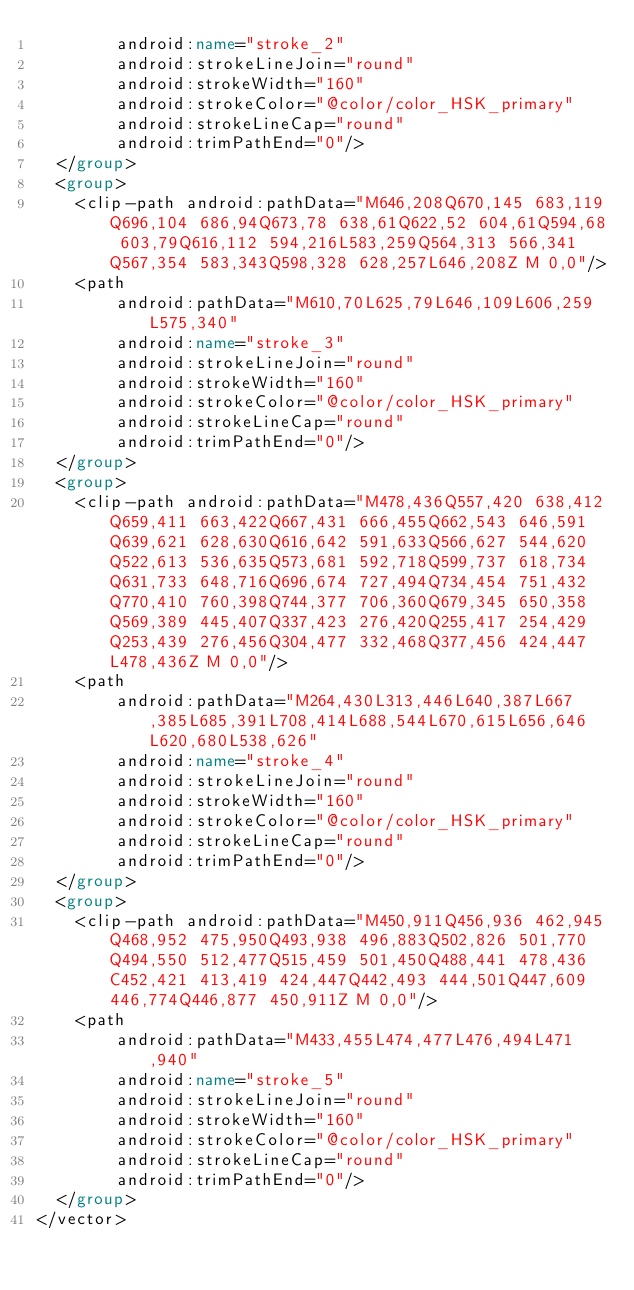<code> <loc_0><loc_0><loc_500><loc_500><_XML_>        android:name="stroke_2"
        android:strokeLineJoin="round"
        android:strokeWidth="160"
        android:strokeColor="@color/color_HSK_primary"
        android:strokeLineCap="round"
        android:trimPathEnd="0"/>
  </group>
  <group>
    <clip-path android:pathData="M646,208Q670,145 683,119Q696,104 686,94Q673,78 638,61Q622,52 604,61Q594,68 603,79Q616,112 594,216L583,259Q564,313 566,341Q567,354 583,343Q598,328 628,257L646,208Z M 0,0"/>
    <path
        android:pathData="M610,70L625,79L646,109L606,259L575,340"
        android:name="stroke_3"
        android:strokeLineJoin="round"
        android:strokeWidth="160"
        android:strokeColor="@color/color_HSK_primary"
        android:strokeLineCap="round"
        android:trimPathEnd="0"/>
  </group>
  <group>
    <clip-path android:pathData="M478,436Q557,420 638,412Q659,411 663,422Q667,431 666,455Q662,543 646,591Q639,621 628,630Q616,642 591,633Q566,627 544,620Q522,613 536,635Q573,681 592,718Q599,737 618,734Q631,733 648,716Q696,674 727,494Q734,454 751,432Q770,410 760,398Q744,377 706,360Q679,345 650,358Q569,389 445,407Q337,423 276,420Q255,417 254,429Q253,439 276,456Q304,477 332,468Q377,456 424,447L478,436Z M 0,0"/>
    <path
        android:pathData="M264,430L313,446L640,387L667,385L685,391L708,414L688,544L670,615L656,646L620,680L538,626"
        android:name="stroke_4"
        android:strokeLineJoin="round"
        android:strokeWidth="160"
        android:strokeColor="@color/color_HSK_primary"
        android:strokeLineCap="round"
        android:trimPathEnd="0"/>
  </group>
  <group>
    <clip-path android:pathData="M450,911Q456,936 462,945Q468,952 475,950Q493,938 496,883Q502,826 501,770Q494,550 512,477Q515,459 501,450Q488,441 478,436C452,421 413,419 424,447Q442,493 444,501Q447,609 446,774Q446,877 450,911Z M 0,0"/>
    <path
        android:pathData="M433,455L474,477L476,494L471,940"
        android:name="stroke_5"
        android:strokeLineJoin="round"
        android:strokeWidth="160"
        android:strokeColor="@color/color_HSK_primary"
        android:strokeLineCap="round"
        android:trimPathEnd="0"/>
  </group>
</vector>
</code> 